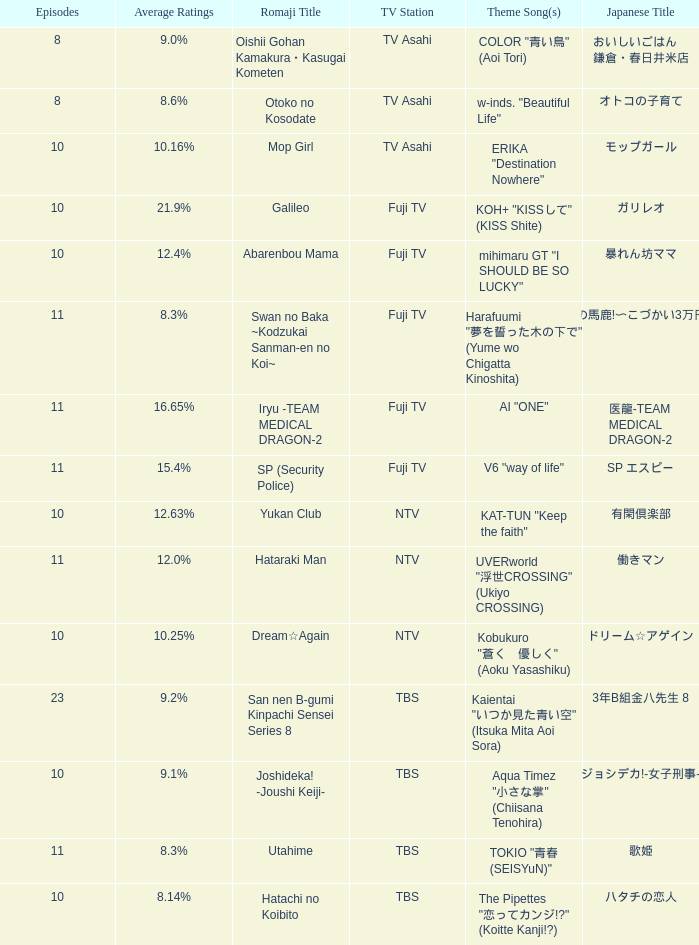Help me parse the entirety of this table. {'header': ['Episodes', 'Average Ratings', 'Romaji Title', 'TV Station', 'Theme Song(s)', 'Japanese Title'], 'rows': [['8', '9.0%', 'Oishii Gohan Kamakura・Kasugai Kometen', 'TV Asahi', 'COLOR "青い鳥" (Aoi Tori)', 'おいしいごはん 鎌倉・春日井米店'], ['8', '8.6%', 'Otoko no Kosodate', 'TV Asahi', 'w-inds. "Beautiful Life"', 'オトコの子育て'], ['10', '10.16%', 'Mop Girl', 'TV Asahi', 'ERIKA "Destination Nowhere"', 'モップガール'], ['10', '21.9%', 'Galileo', 'Fuji TV', 'KOH+ "KISSして" (KISS Shite)', 'ガリレオ'], ['10', '12.4%', 'Abarenbou Mama', 'Fuji TV', 'mihimaru GT "I SHOULD BE SO LUCKY"', '暴れん坊ママ'], ['11', '8.3%', 'Swan no Baka ~Kodzukai Sanman-en no Koi~', 'Fuji TV', 'Harafuumi "夢を誓った木の下で" (Yume wo Chigatta Kinoshita)', 'スワンの馬鹿!〜こづかい3万円の恋〜'], ['11', '16.65%', 'Iryu -TEAM MEDICAL DRAGON-2', 'Fuji TV', 'AI "ONE"', '医龍-TEAM MEDICAL DRAGON-2'], ['11', '15.4%', 'SP (Security Police)', 'Fuji TV', 'V6 "way of life"', 'SP エスピー'], ['10', '12.63%', 'Yukan Club', 'NTV', 'KAT-TUN "Keep the faith"', '有閑倶楽部'], ['11', '12.0%', 'Hataraki Man', 'NTV', 'UVERworld "浮世CROSSING" (Ukiyo CROSSING)', '働きマン'], ['10', '10.25%', 'Dream☆Again', 'NTV', 'Kobukuro "蒼く\u3000優しく" (Aoku Yasashiku)', 'ドリーム☆アゲイン'], ['23', '9.2%', 'San nen B-gumi Kinpachi Sensei Series 8', 'TBS', 'Kaientai "いつか見た青い空" (Itsuka Mita Aoi Sora)', '3年B組金八先生 8'], ['10', '9.1%', 'Joshideka! -Joushi Keiji-', 'TBS', 'Aqua Timez "小さな掌" (Chiisana Tenohira)', 'ジョシデカ!-女子刑事-'], ['11', '8.3%', 'Utahime', 'TBS', 'TOKIO "青春 (SEISYuN)"', '歌姫'], ['10', '8.14%', 'Hatachi no Koibito', 'TBS', 'The Pipettes "恋ってカンジ!?" (Koitte Kanji!?)', 'ハタチの恋人']]} What is the Theme Song of 働きマン? UVERworld "浮世CROSSING" (Ukiyo CROSSING). 